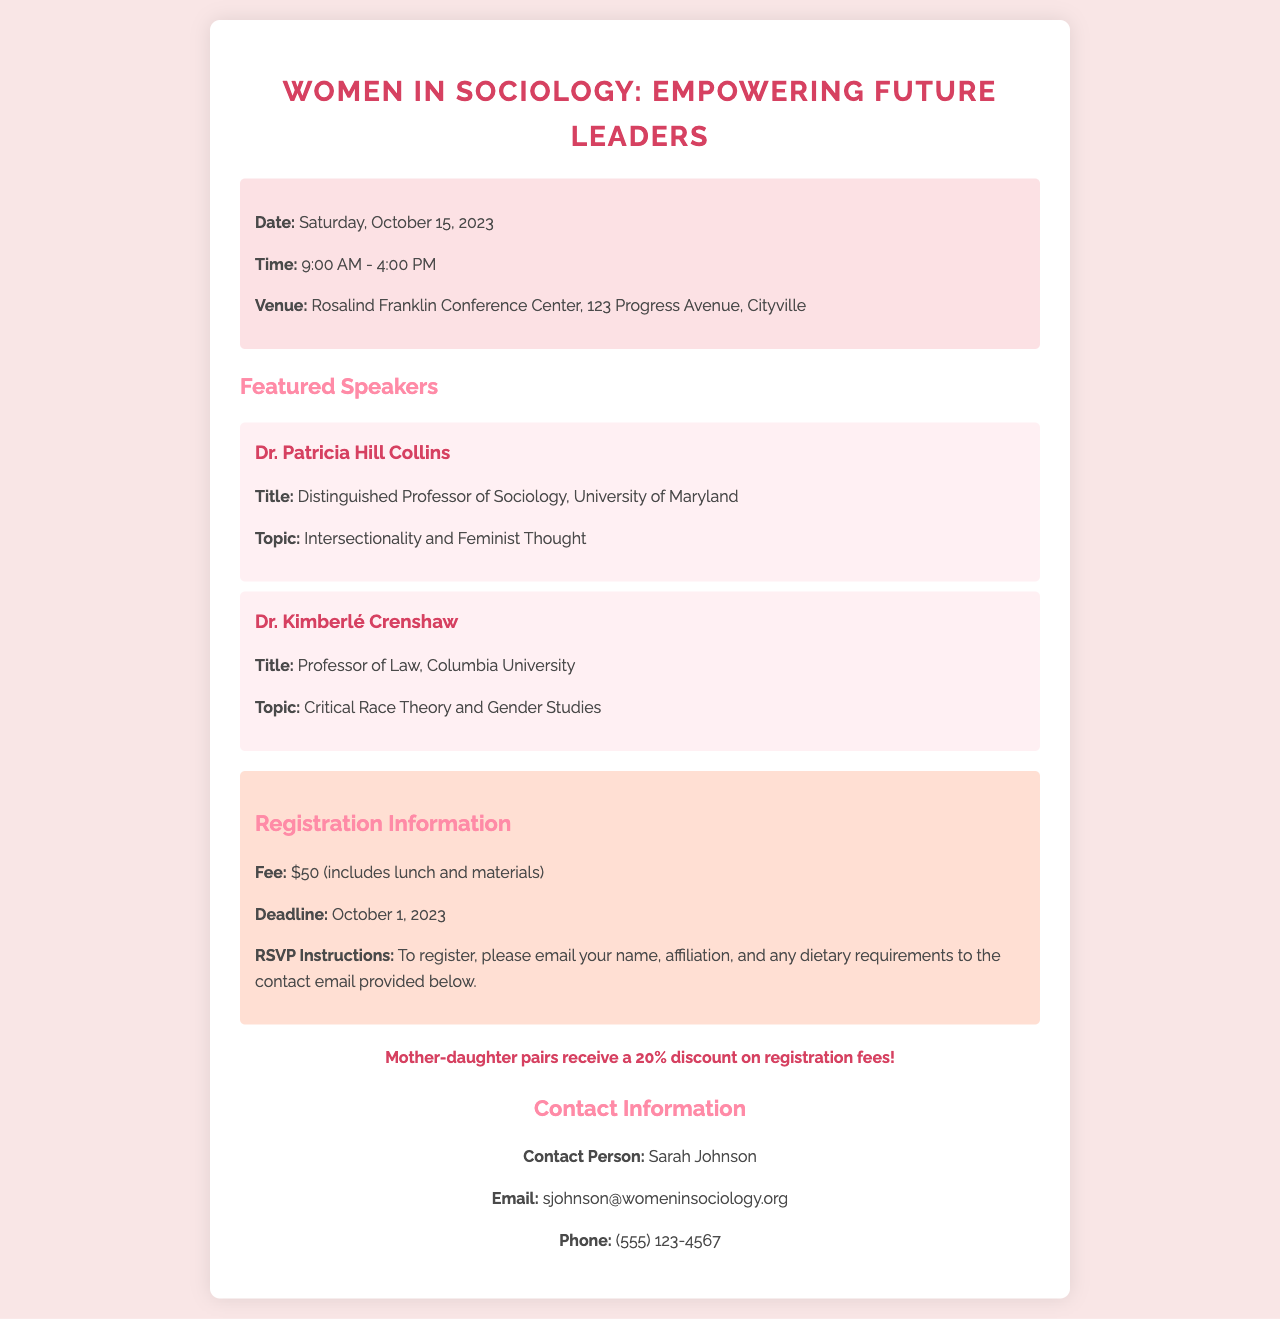What is the date of the seminar? The date is specifically mentioned in the event details section of the document.
Answer: Saturday, October 15, 2023 What is the registration fee? The fee is listed prominently in the registration information section of the document.
Answer: $50 Who is one of the featured speakers? The names of the featured speakers are provided in the document, making it easy to identify one.
Answer: Dr. Patricia Hill Collins What topic will Dr. Kimberlé Crenshaw discuss? The topic assigned to Dr. Kimberlé Crenshaw is stated directly under her name in the speaker section.
Answer: Critical Race Theory and Gender Studies What is the registration deadline? The registration deadline is explicitly mentioned in the registration section of the document.
Answer: October 1, 2023 How long will the seminar last? The time range is stated in the event details section, indicating the duration of the seminar.
Answer: 9:00 AM - 4:00 PM What type of event is being invited? The main theme of the seminar is evident from the title, indicating the event's focus.
Answer: Women's empowerment seminar Is there a discount for mother-daughter pairs? The special note section highlights a promotional detail regarding registration fees.
Answer: Yes, 20% discount Who should people contact for further information? The contact person is explicitly named in the contact information section, providing clarity for inquiries.
Answer: Sarah Johnson 